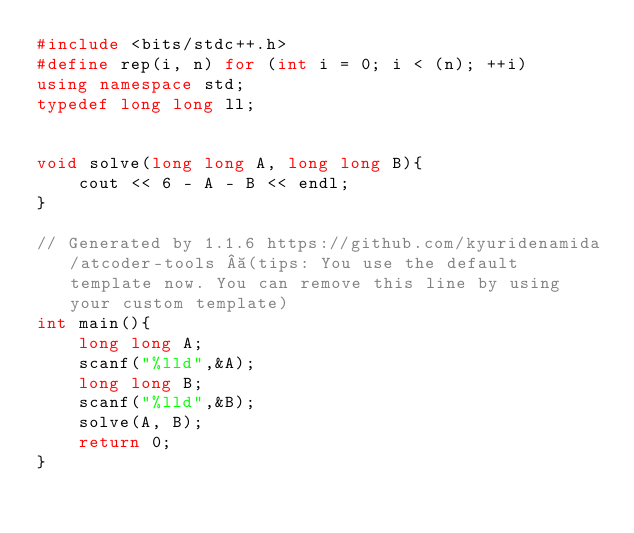Convert code to text. <code><loc_0><loc_0><loc_500><loc_500><_C++_>#include <bits/stdc++.h>
#define rep(i, n) for (int i = 0; i < (n); ++i) 
using namespace std;
typedef long long ll;


void solve(long long A, long long B){
    cout << 6 - A - B << endl;
}

// Generated by 1.1.6 https://github.com/kyuridenamida/atcoder-tools  (tips: You use the default template now. You can remove this line by using your custom template)
int main(){
    long long A;
    scanf("%lld",&A);
    long long B;
    scanf("%lld",&B);
    solve(A, B);
    return 0;
}
</code> 